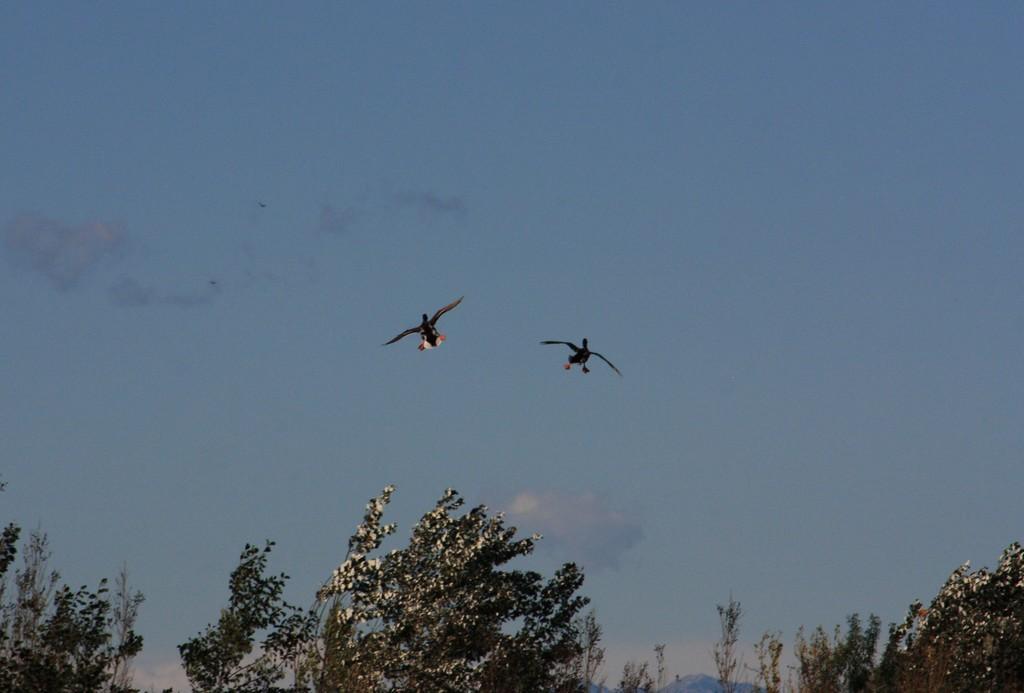Please provide a concise description of this image. In this image two birds are flying in air. Bottom of image there are few trees, behind there is a hill. Top of image there is sky. 